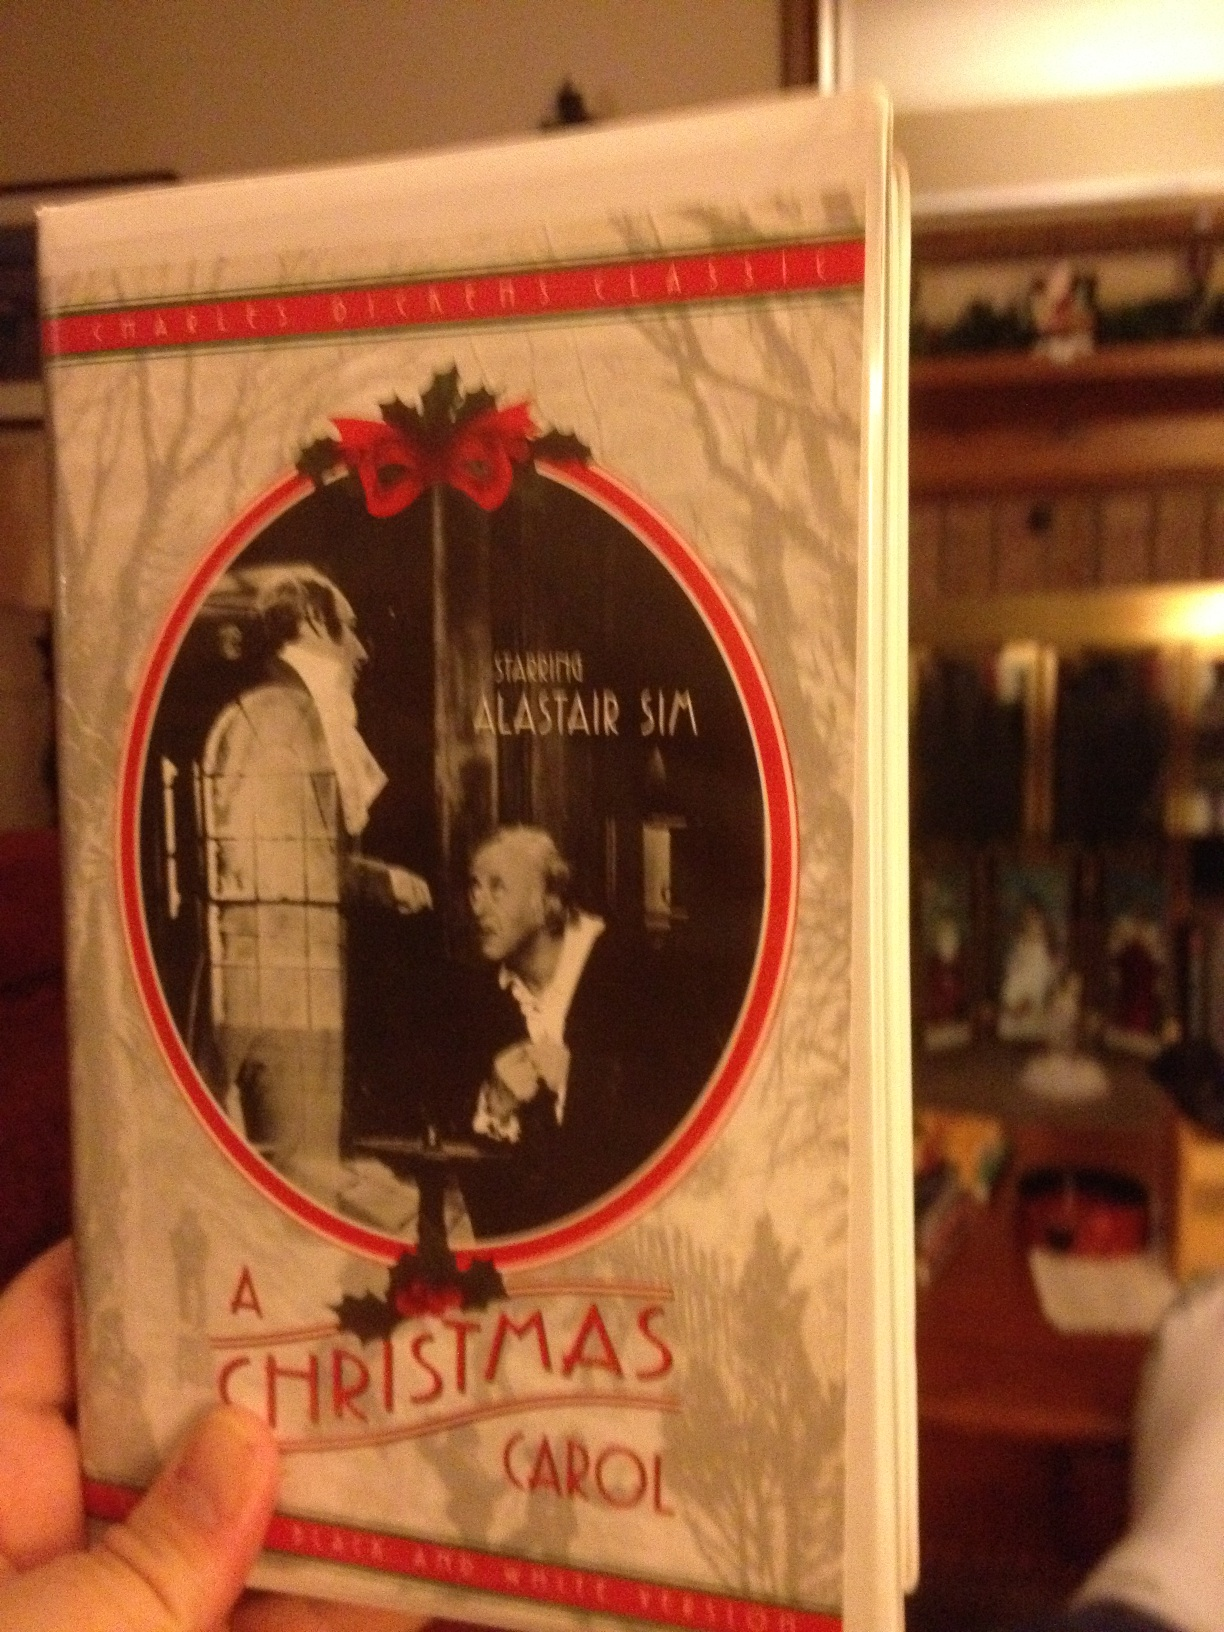If you were to add a new character to the story, who or what would it be, and why? If I were to add a new character to 'A Christmas Carol', it would be the Spirit of Christmas Future Possibilities. Unlike the Ghost of Christmas Yet to Come, who shows a potential dark future, this new spirit would present multiple potential futures based on varied paths Scrooge could take in life, emphasizing the impact of even small acts of kindness or neglect. This addition would reinforce the story's message that every action, however insignificant it may seem, creates ripples affecting both oneself and the broader community. The Spirit of Christmas Future Possibilities would inspire not only fear of a negative outcome but also hope and motivation, encouraging Scrooge to actively shape a better and more compassionate future. 